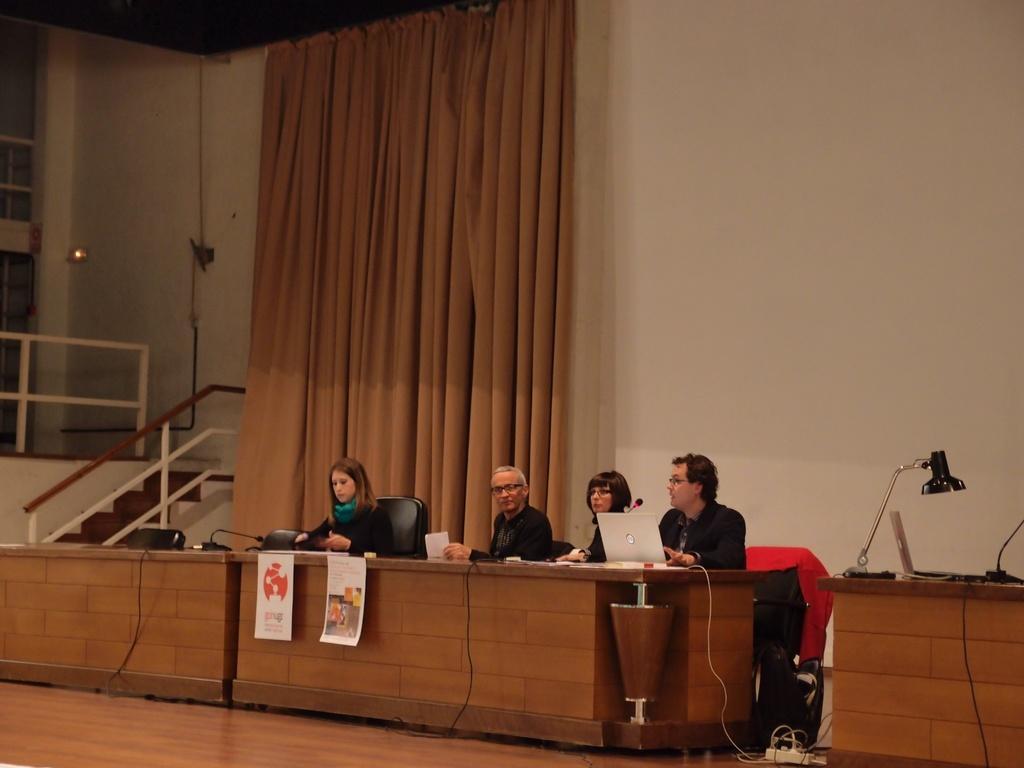How would you summarize this image in a sentence or two? In a room there are four people sitting in front of a table, on the table there is a laptop, some papers and other equipment. Behind them there is a curtain and on the left side there are stairs. Beside that table there are some other items kept on another table. 